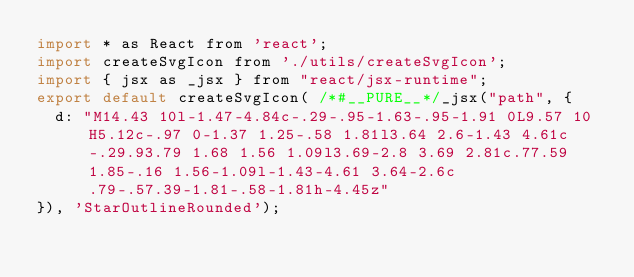Convert code to text. <code><loc_0><loc_0><loc_500><loc_500><_JavaScript_>import * as React from 'react';
import createSvgIcon from './utils/createSvgIcon';
import { jsx as _jsx } from "react/jsx-runtime";
export default createSvgIcon( /*#__PURE__*/_jsx("path", {
  d: "M14.43 10l-1.47-4.84c-.29-.95-1.63-.95-1.91 0L9.57 10H5.12c-.97 0-1.37 1.25-.58 1.81l3.64 2.6-1.43 4.61c-.29.93.79 1.68 1.56 1.09l3.69-2.8 3.69 2.81c.77.59 1.85-.16 1.56-1.09l-1.43-4.61 3.64-2.6c.79-.57.39-1.81-.58-1.81h-4.45z"
}), 'StarOutlineRounded');</code> 